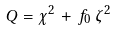<formula> <loc_0><loc_0><loc_500><loc_500>Q = \chi ^ { 2 } \, + \, f _ { 0 } \, \zeta ^ { 2 }</formula> 